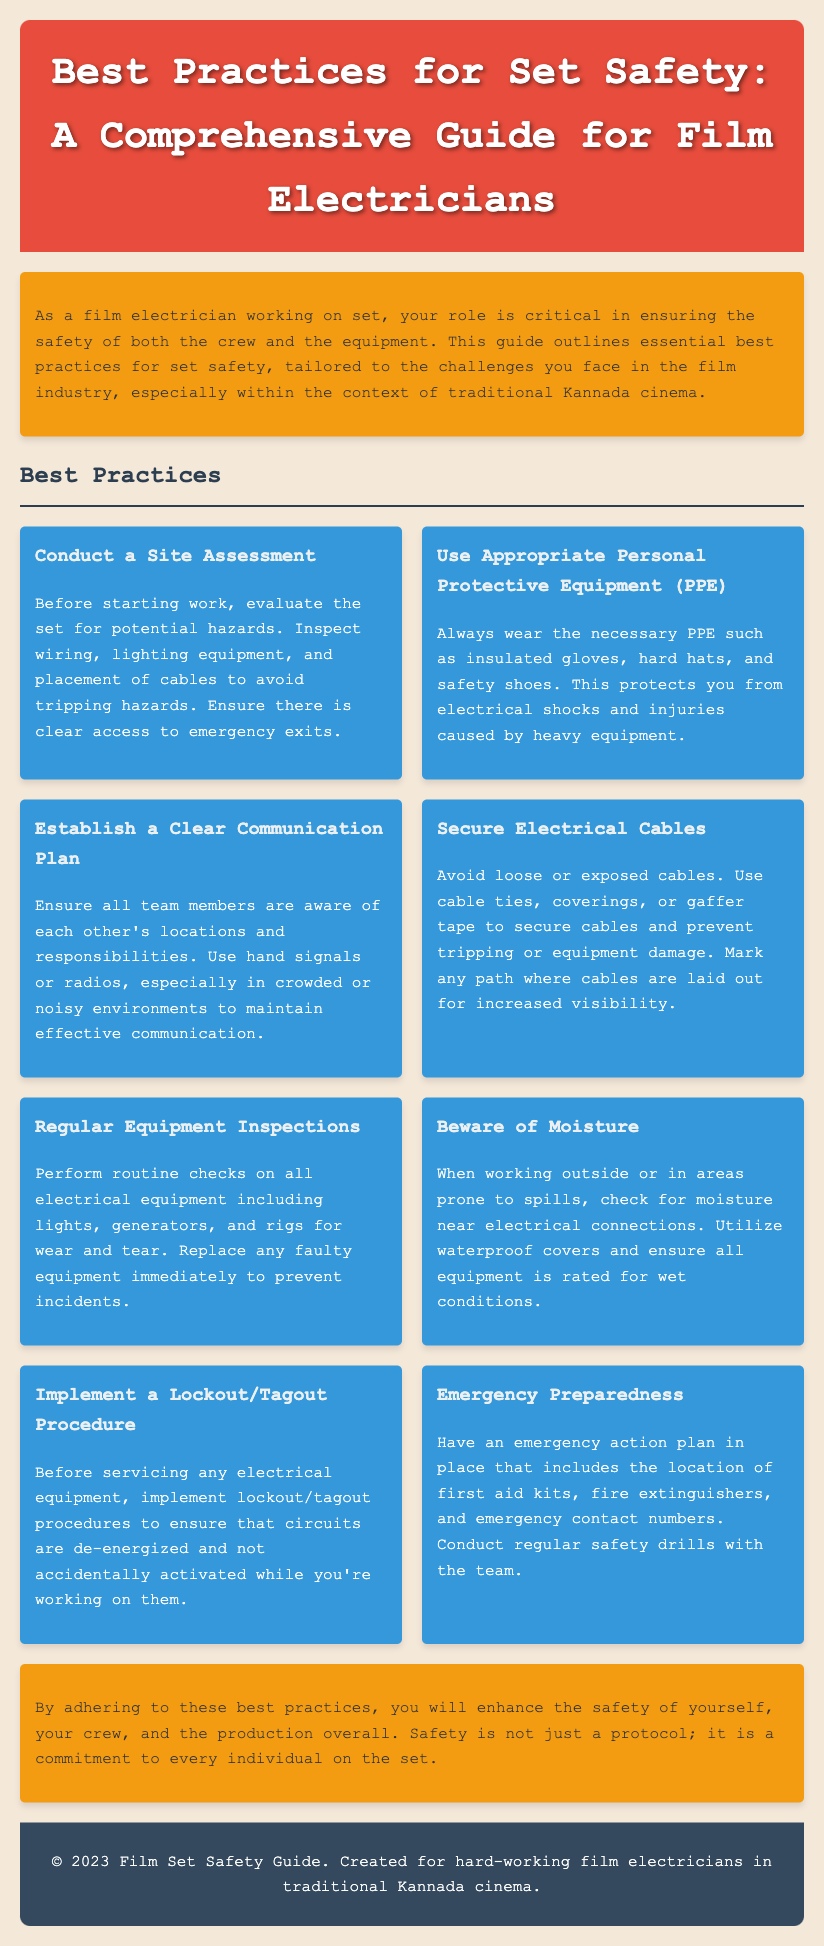What is the title of the document? The title is found in the header of the document.
Answer: Best Practices for Set Safety: A Comprehensive Guide for Film Electricians What type of equipment is mentioned for personal protection? The document states types of personal protective equipment required for electricians.
Answer: Insulated gloves, hard hats, safety shoes How many best practices are listed in the document? The number of practices can be found by counting the items in the best practices section.
Answer: Eight What should you do before starting work on set? The document advises essential steps to ensure safety before beginning work.
Answer: Conduct a Site Assessment What is the purpose of the lockout/tagout procedure? This procedure is essential for dealing with electrical equipment safely according to the manual.
Answer: To ensure circuits are de-energized What is the main focus of this guide? The document highlights the primary intent of the guide concerning safety.
Answer: Enhancing safety for film electricians Where should first aid kits be located? The document mentions preparedness for emergency action plans.
Answer: In the emergency action plan How should electrical cables be handled? The guide emphasizes the proper management of electrical cables to ensure set safety.
Answer: Secure Electrical Cables 